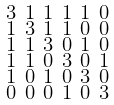Convert formula to latex. <formula><loc_0><loc_0><loc_500><loc_500>\begin{smallmatrix} 3 & 1 & 1 & 1 & 1 & 0 \\ 1 & 3 & 1 & 1 & 0 & 0 \\ 1 & 1 & 3 & 0 & 1 & 0 \\ 1 & 1 & 0 & 3 & 0 & 1 \\ 1 & 0 & 1 & 0 & 3 & 0 \\ 0 & 0 & 0 & 1 & 0 & 3 \end{smallmatrix}</formula> 